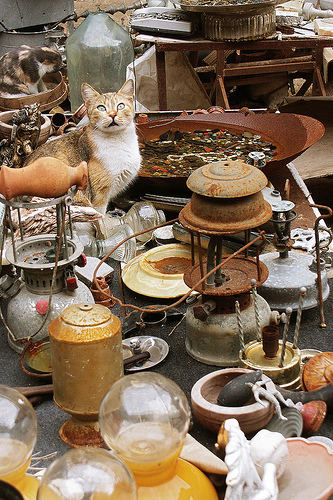<image>
Can you confirm if the cat is to the right of the bottle? No. The cat is not to the right of the bottle. The horizontal positioning shows a different relationship. 